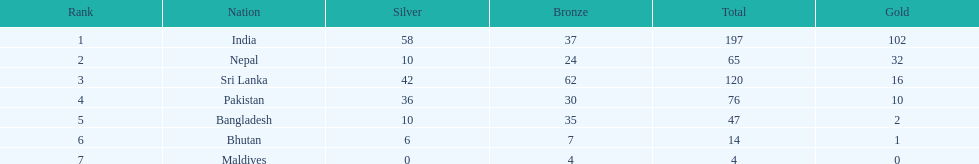Name a country listed in the table, other than india? Nepal. 